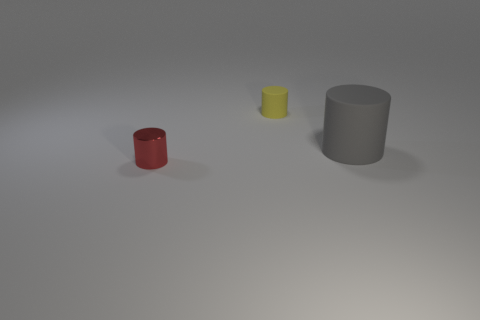What might be the use of these cylinders in a real-world context? The cylinders could be containers or parts of machinery. The small red one could be a cup or a holder, the yellow might be a decorative piece, and the larger grey cylinder could be part of an industrial pipe system or a storage container. 